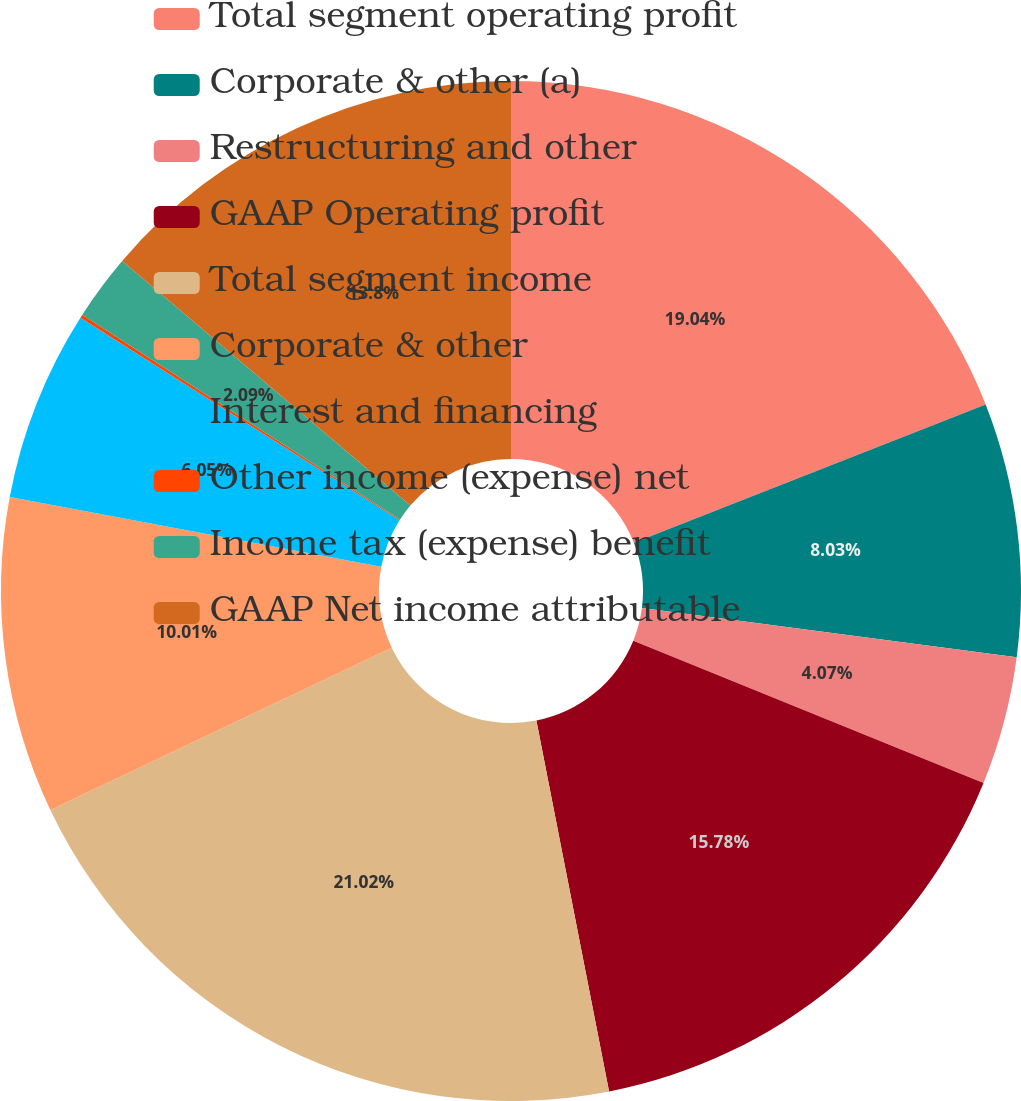Convert chart to OTSL. <chart><loc_0><loc_0><loc_500><loc_500><pie_chart><fcel>Total segment operating profit<fcel>Corporate & other (a)<fcel>Restructuring and other<fcel>GAAP Operating profit<fcel>Total segment income<fcel>Corporate & other<fcel>Interest and financing<fcel>Other income (expense) net<fcel>Income tax (expense) benefit<fcel>GAAP Net income attributable<nl><fcel>19.04%<fcel>8.03%<fcel>4.07%<fcel>15.78%<fcel>21.02%<fcel>10.01%<fcel>6.05%<fcel>0.11%<fcel>2.09%<fcel>13.8%<nl></chart> 